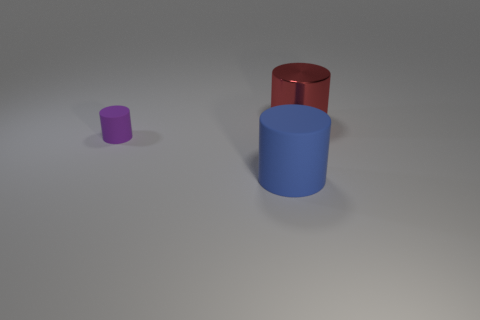Add 2 green things. How many objects exist? 5 Add 2 blue cylinders. How many blue cylinders are left? 3 Add 3 large blue shiny cubes. How many large blue shiny cubes exist? 3 Subtract 1 purple cylinders. How many objects are left? 2 Subtract all purple balls. Subtract all small purple rubber cylinders. How many objects are left? 2 